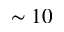Convert formula to latex. <formula><loc_0><loc_0><loc_500><loc_500>\sim 1 0</formula> 